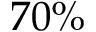<formula> <loc_0><loc_0><loc_500><loc_500>7 0 \%</formula> 